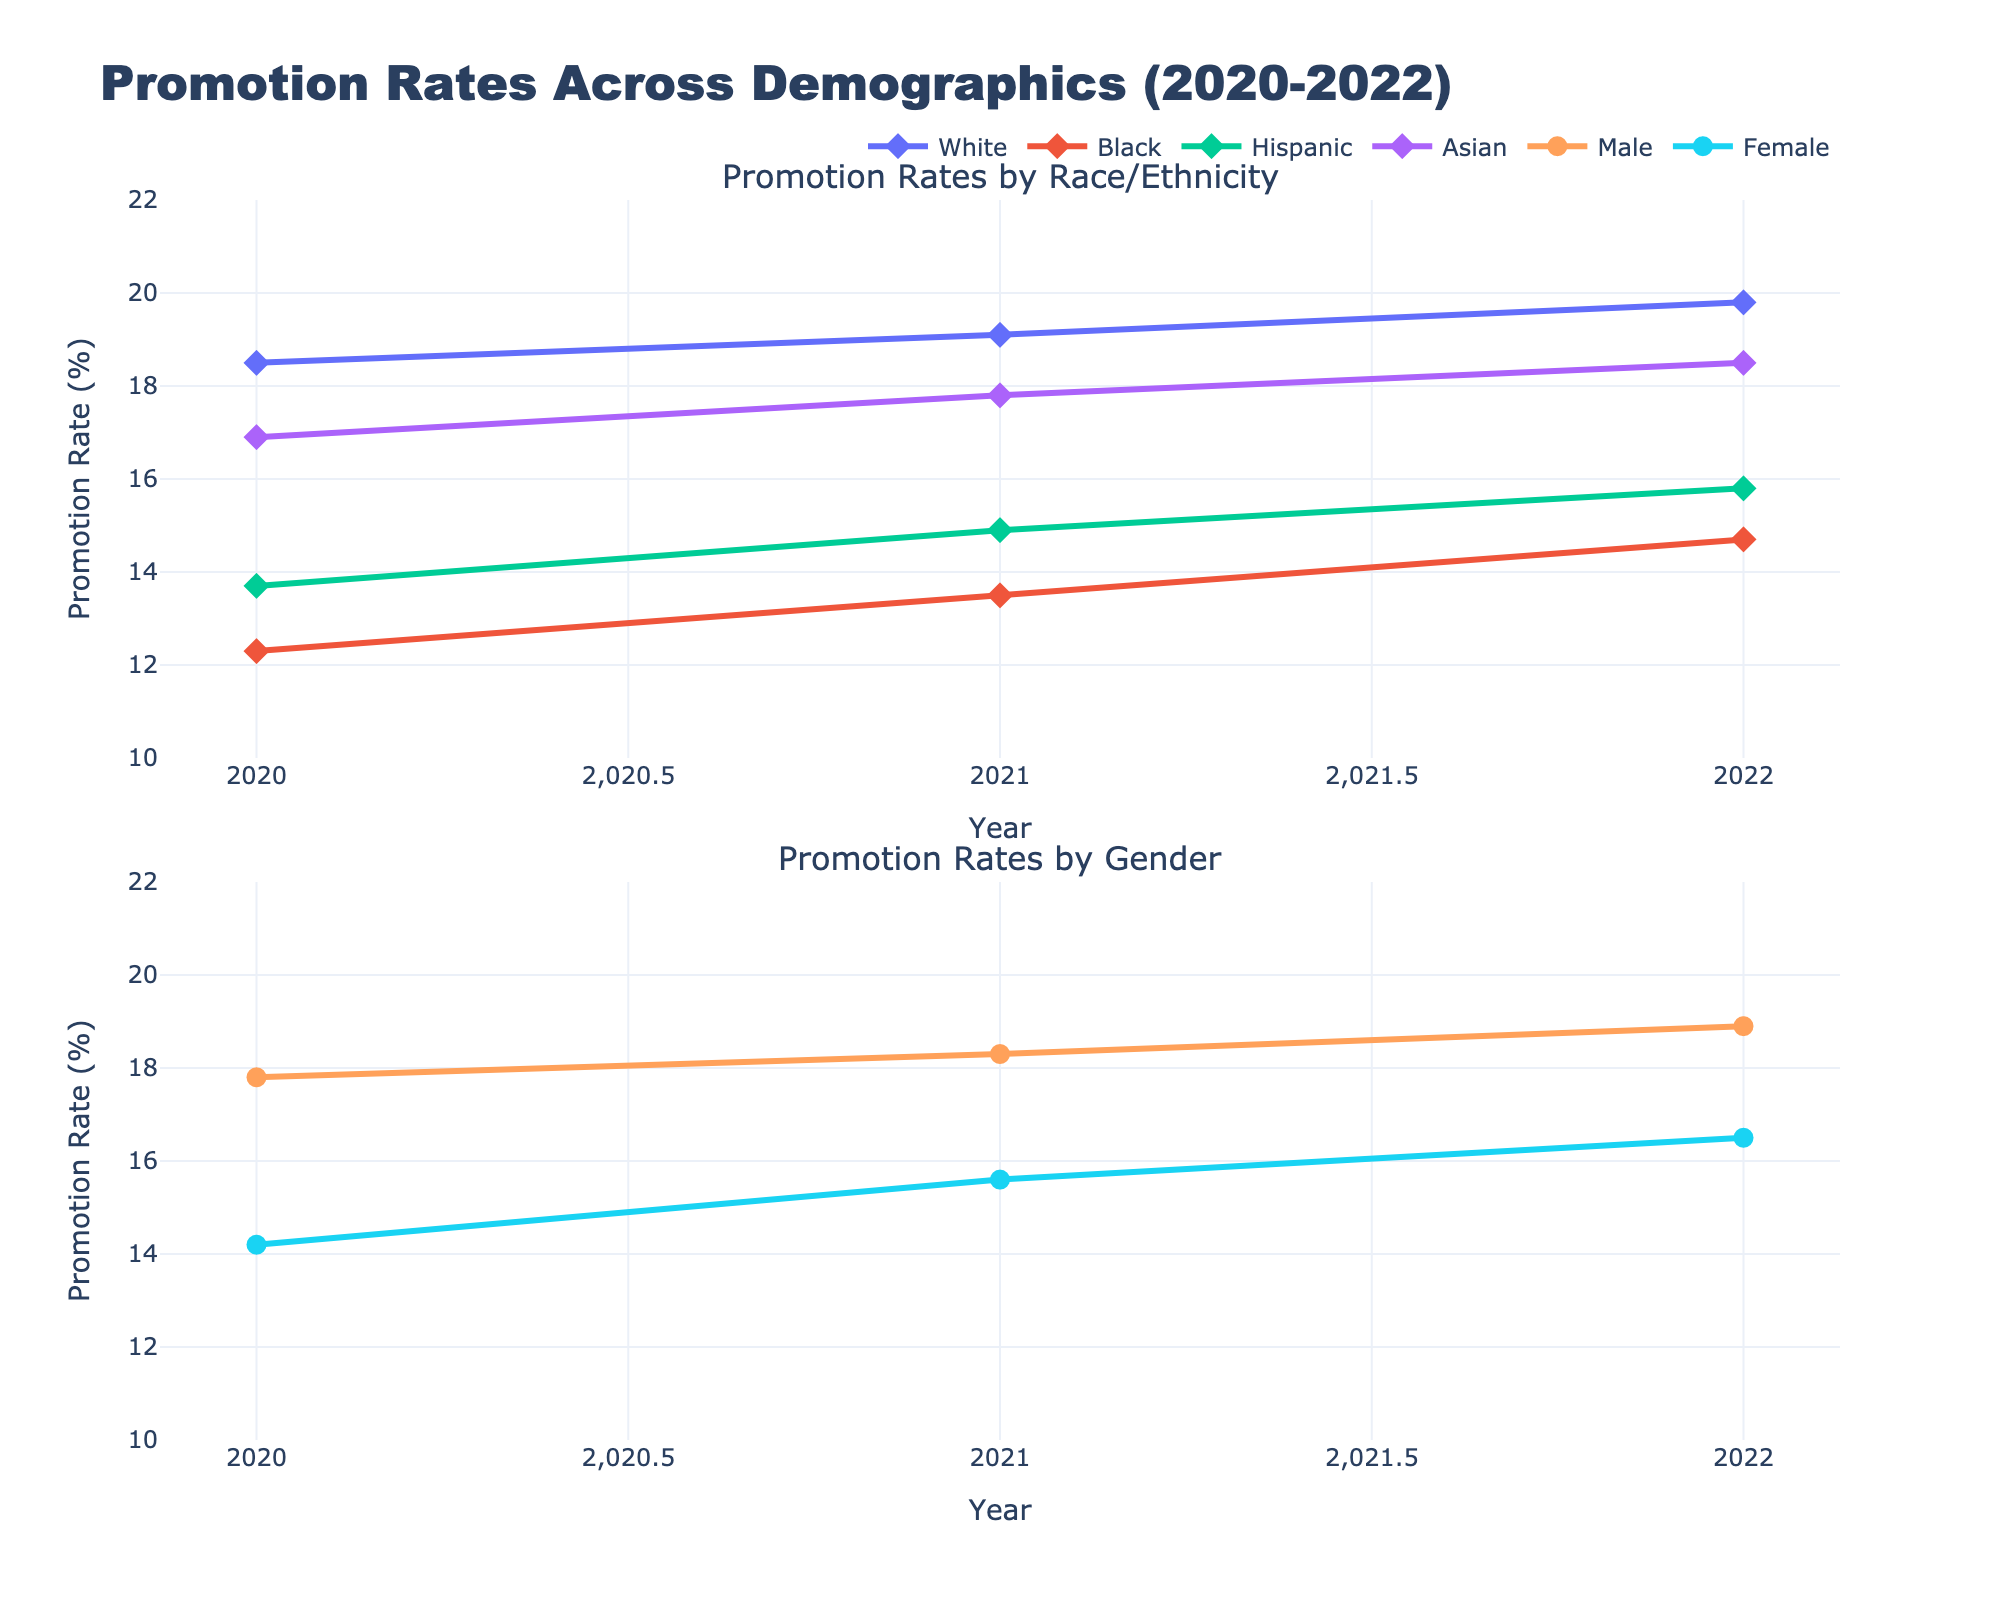What is the title of the figure? The title is located at the top of the figure, indicating the main subject of the data presented in the subplots. The title reads "Promotion Rates Across Demographics (2020-2022)."
Answer: Promotion Rates Across Demographics (2020-2022) What is the promotion rate for White employees in 2021? To find the promotion rate for White employees in 2021, look for the data point corresponding to the year 2021 on the 'Promotion Rates by Race/Ethnicity' subplot and specifically for the White demographic group.
Answer: 19.1% Which year shows the highest promotion rate for Female employees? Inspect the 'Promotion Rates by Gender' subplot and identify the data points for Female employees across the years 2020 to 2022, noting the highest value among them.
Answer: 2022 What is the difference in promotion rates between Male and Female employees in 2022? First, find the promotion rates for Male employees (18.9%) and Female employees (16.5%) in 2022 from the 'Promotion Rates by Gender' subplot. Then calculate the difference: 18.9% - 16.5% = 2.4%.
Answer: 2.4% Which racial/ethnic group had the lowest promotion rate in 2020? Examine the 'Promotion Rates by Race/Ethnicity' subplot for the year 2020 and identify the group with the lowest promotion rate by comparing the values for White, Black, Hispanic, and Asian groups.
Answer: Black By how much did the promotion rate for Hispanic employees increase from 2020 to 2022? Locate the promotion rates for Hispanic employees in 2020 (13.7%) and 2022 (15.8%) from the 'Promotion Rates by Race/Ethnicity' subplot. Subtract the 2020 value from the 2022 value: 15.8% - 13.7% = 2.1%.
Answer: 2.1% Which group showed a consistent increase in promotion rates over the three years? Analyze the trends for each demographic group in both subplots from 2020 to 2022. The groups with consistently increasing trends will be identified. The White, Black, Hispanic, and Asian groups all show increasing promotion rates.
Answer: White, Black, Hispanic, and Asian How do the promotion rates of Asian employees in 2020 compare to those of Female employees in 2021? Reference the 'Promotion Rates by Race/Ethnicity' subplot for Asian employees in 2020 (16.9%) and the 'Promotion Rates by Gender' subplot for Female employees in 2021 (15.6%). Compare the promotion rates directly.
Answer: 16.9% vs 15.6% What can you infer about the trends in promotion rates for Male and Female employees over the given years? Review the 'Promotion Rates by Gender' subplot to observe the trends for both Male and Female employees from 2020 to 2022. Both Male and Female employees show an increasing trend in their promotion rates, with males consistently having higher rates.
Answer: Increasing for both, males consistently higher 